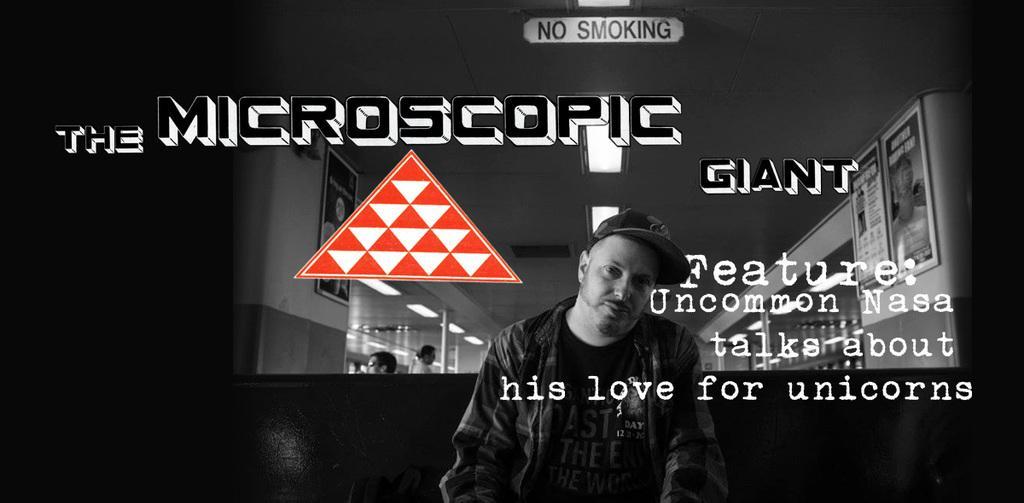Can you describe this image briefly? On the picture there is text. This is a black and white picture. In the foreground of the picture there is a man sitting in a couch. In the background there are lights, glass windows, posters and people. 